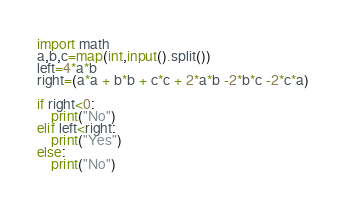<code> <loc_0><loc_0><loc_500><loc_500><_Python_>import math
a,b,c=map(int,input().split())
left=4*a*b
right=(a*a + b*b + c*c + 2*a*b -2*b*c -2*c*a)

if right<0:
    print("No")
elif left<right:
    print("Yes")
else:
    print("No")</code> 